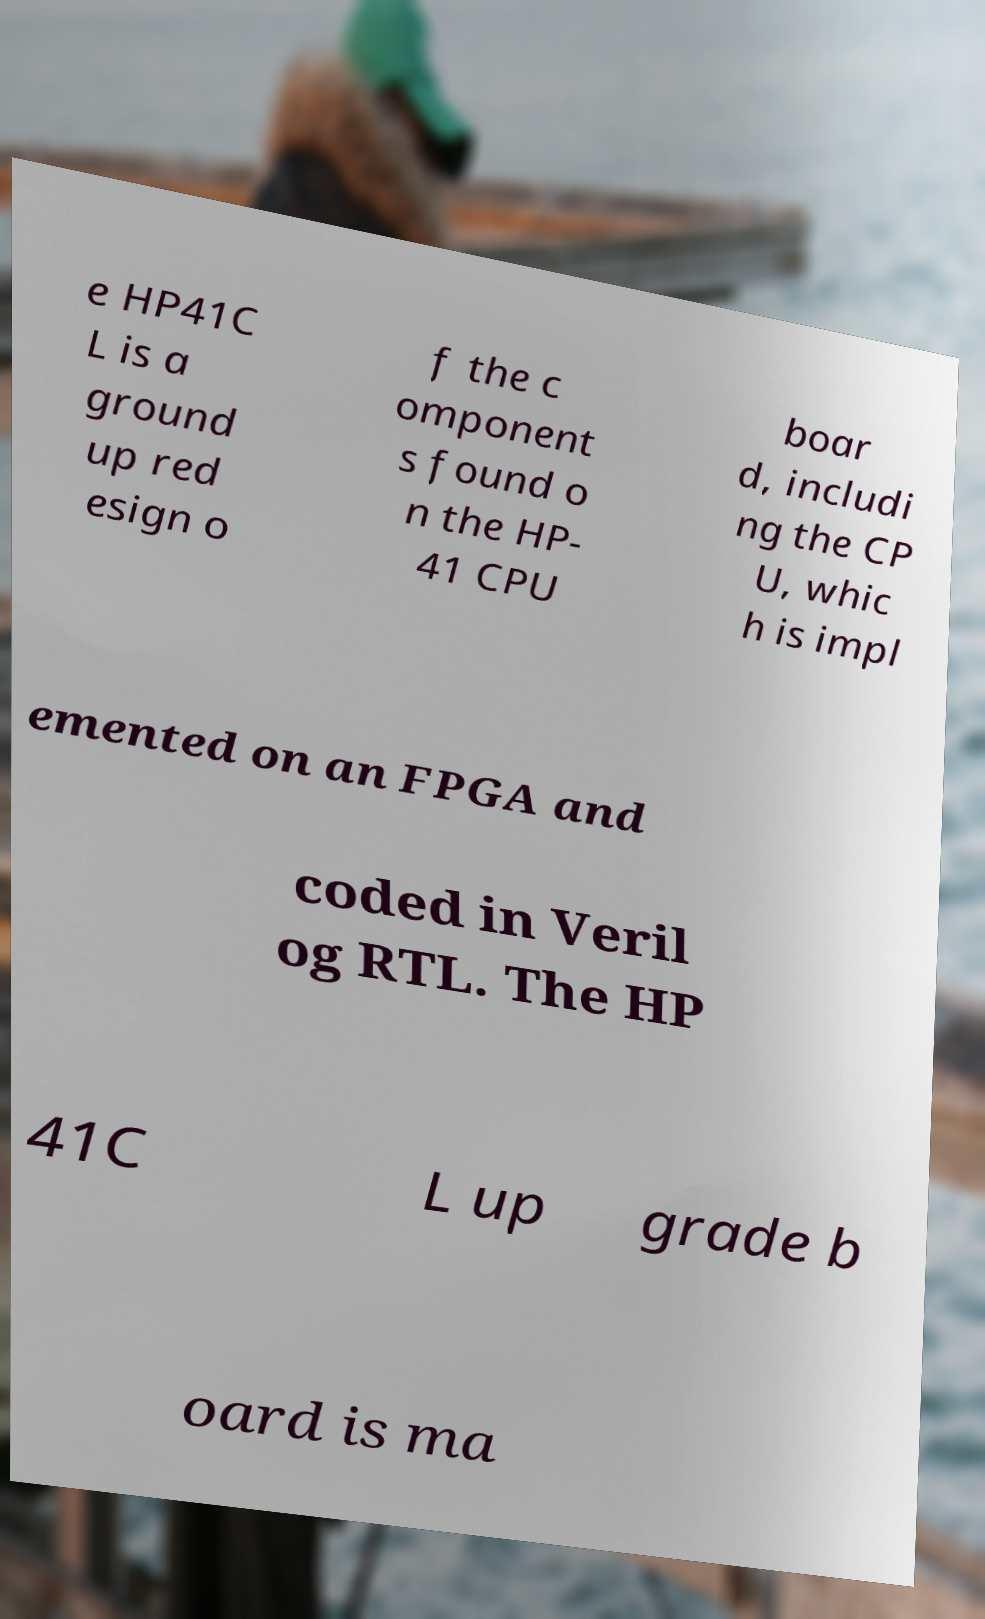There's text embedded in this image that I need extracted. Can you transcribe it verbatim? e HP41C L is a ground up red esign o f the c omponent s found o n the HP- 41 CPU boar d, includi ng the CP U, whic h is impl emented on an FPGA and coded in Veril og RTL. The HP 41C L up grade b oard is ma 